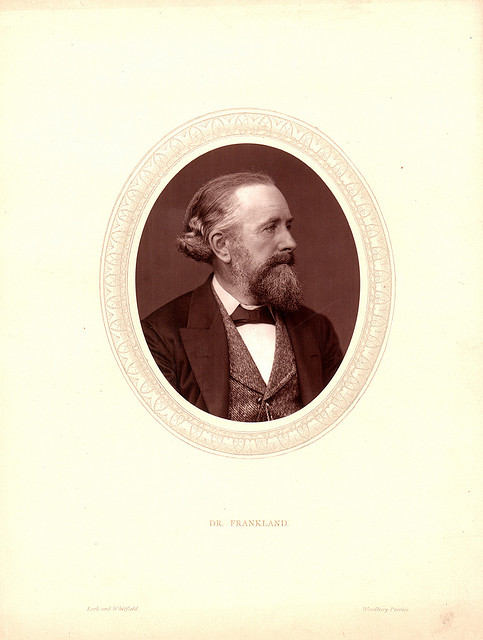<image>Who is in the photo? I don't know who is in the photo. It could be Frankland, Assanti, Dr Freeland, or just a man or a person. Who is in the photo? I don't know who is in the photo. It can be seen as Frankland, Assanti, Dr. Freeland or just a man. 